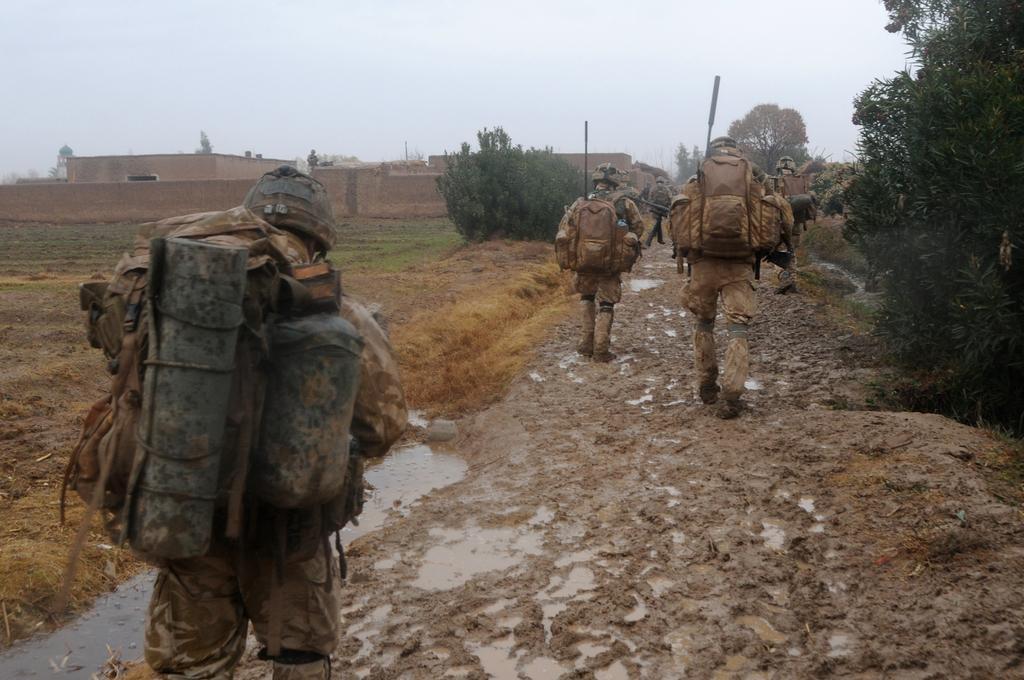Could you give a brief overview of what you see in this image? In this picture I can observe some people walking on the land. I can observe some water in the bottom of the picture. In the background there are trees, building and sky. 